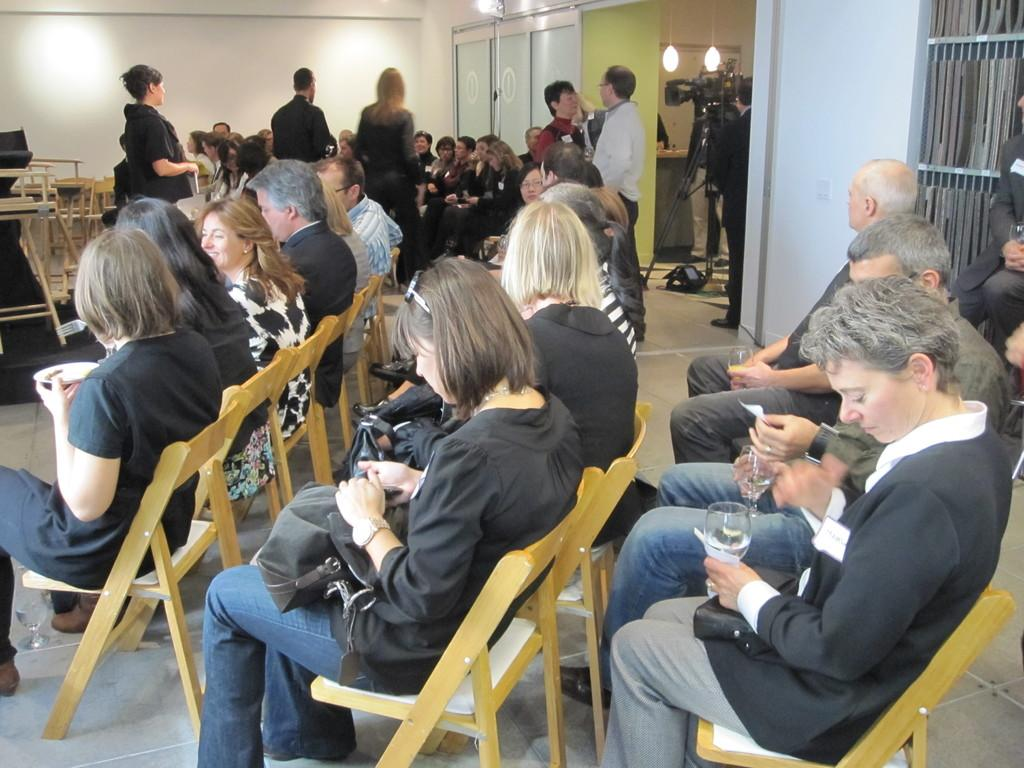What are the people in the image doing? There is a group of people seated on chairs, and some people are holding wine glasses. Are there any people standing in the image? Yes, there are people standing in the image. What is the person with the camera doing? The person with the camera is standing. Can you describe the activity of the person holding the camera? The person holding the camera is likely taking a photograph or recording a video. What type of competition is taking place in the image? There is no competition present in the image; it features a group of people seated and standing, with some holding wine glasses and one person holding a camera. Can you tell me how many airports are visible in the image? There are no airports present in the image. 